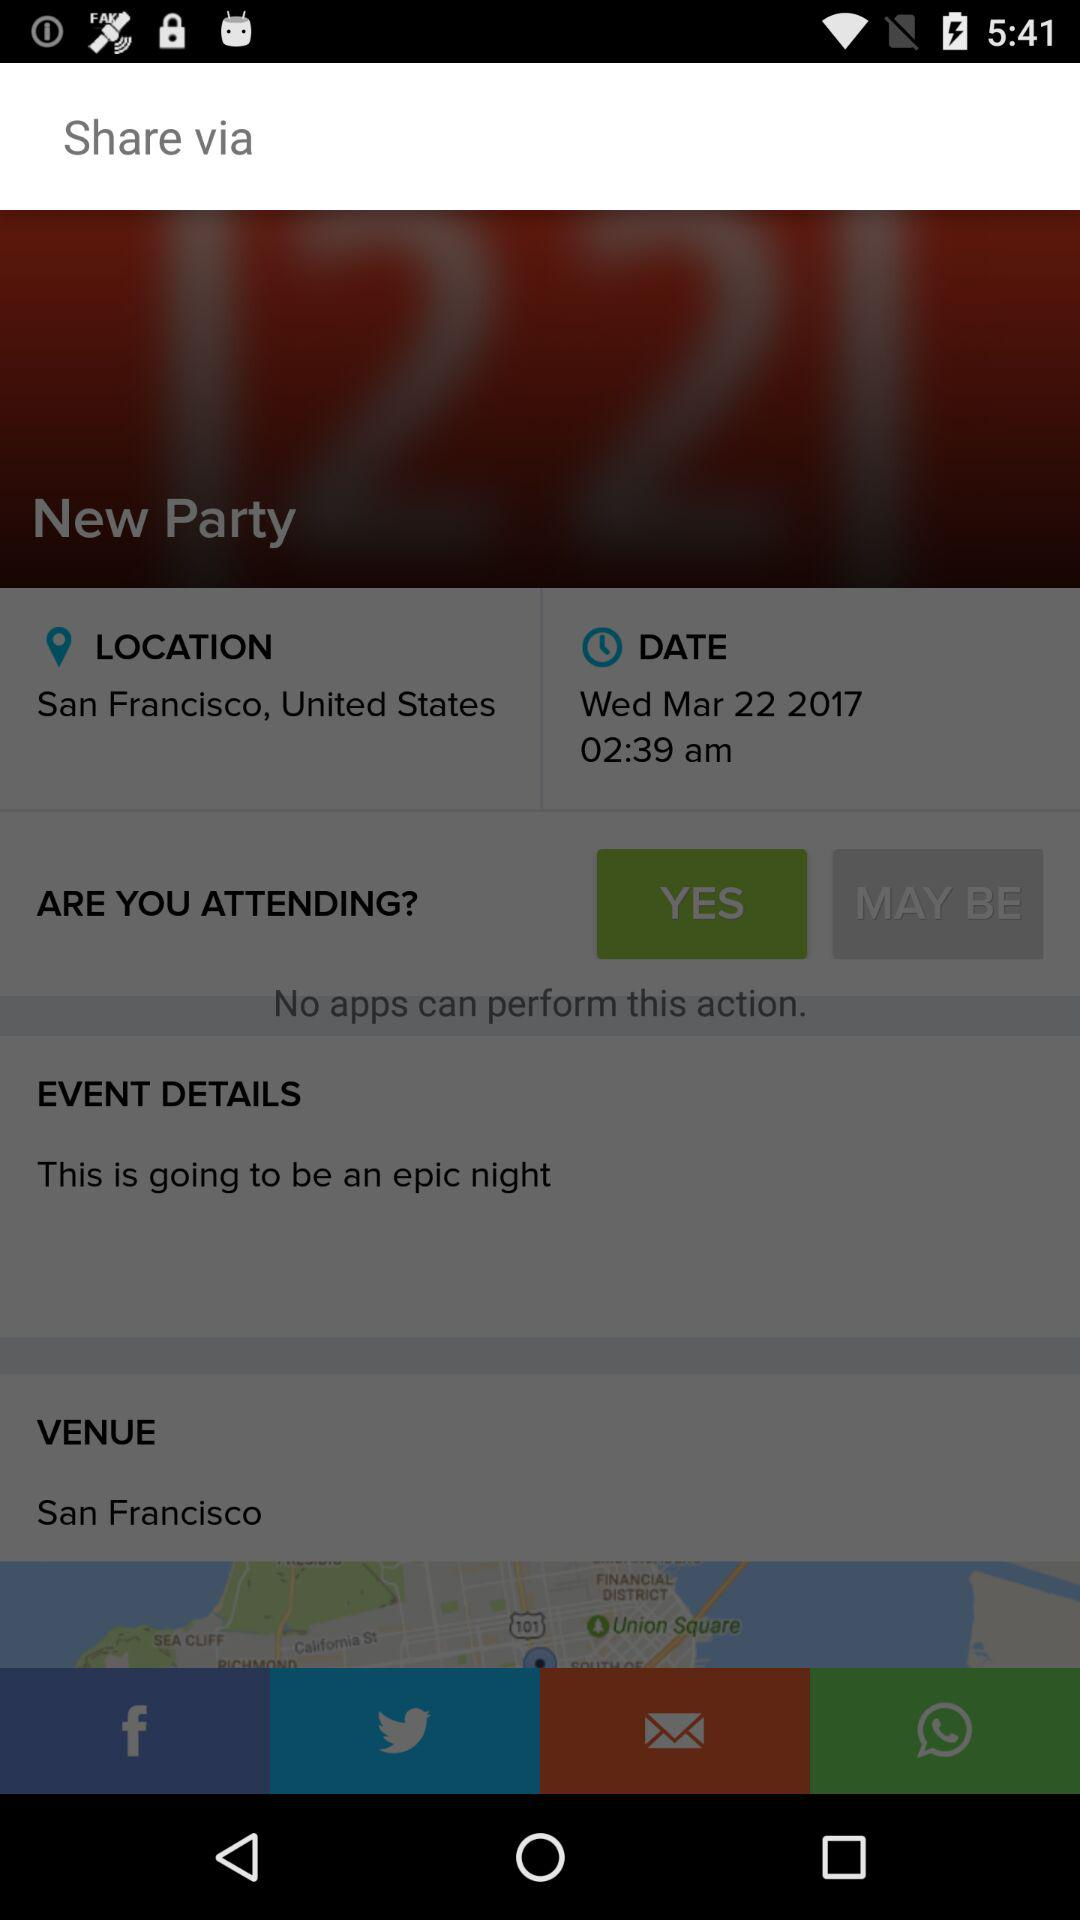What type of event is it going to be? It is going to be an epic night. 